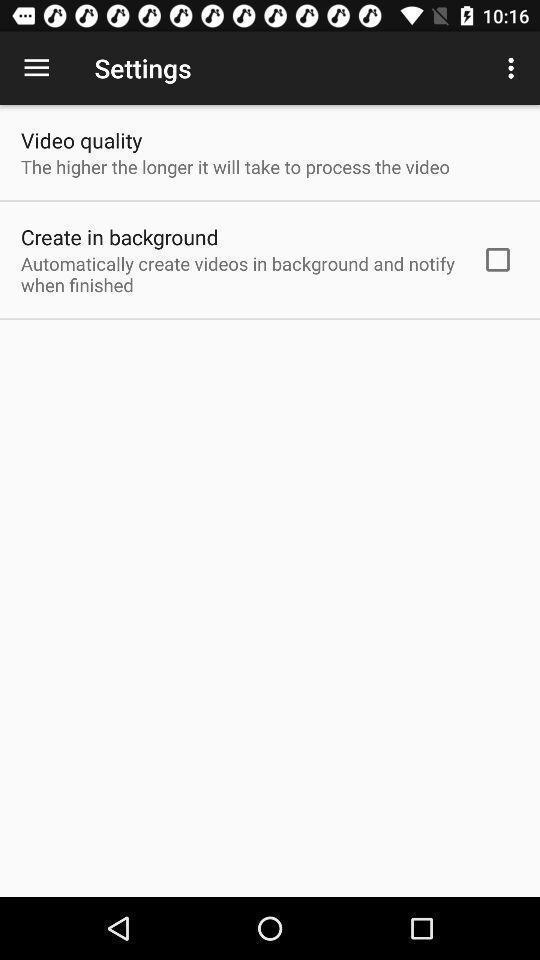Give me a narrative description of this picture. Page showing settings options. 